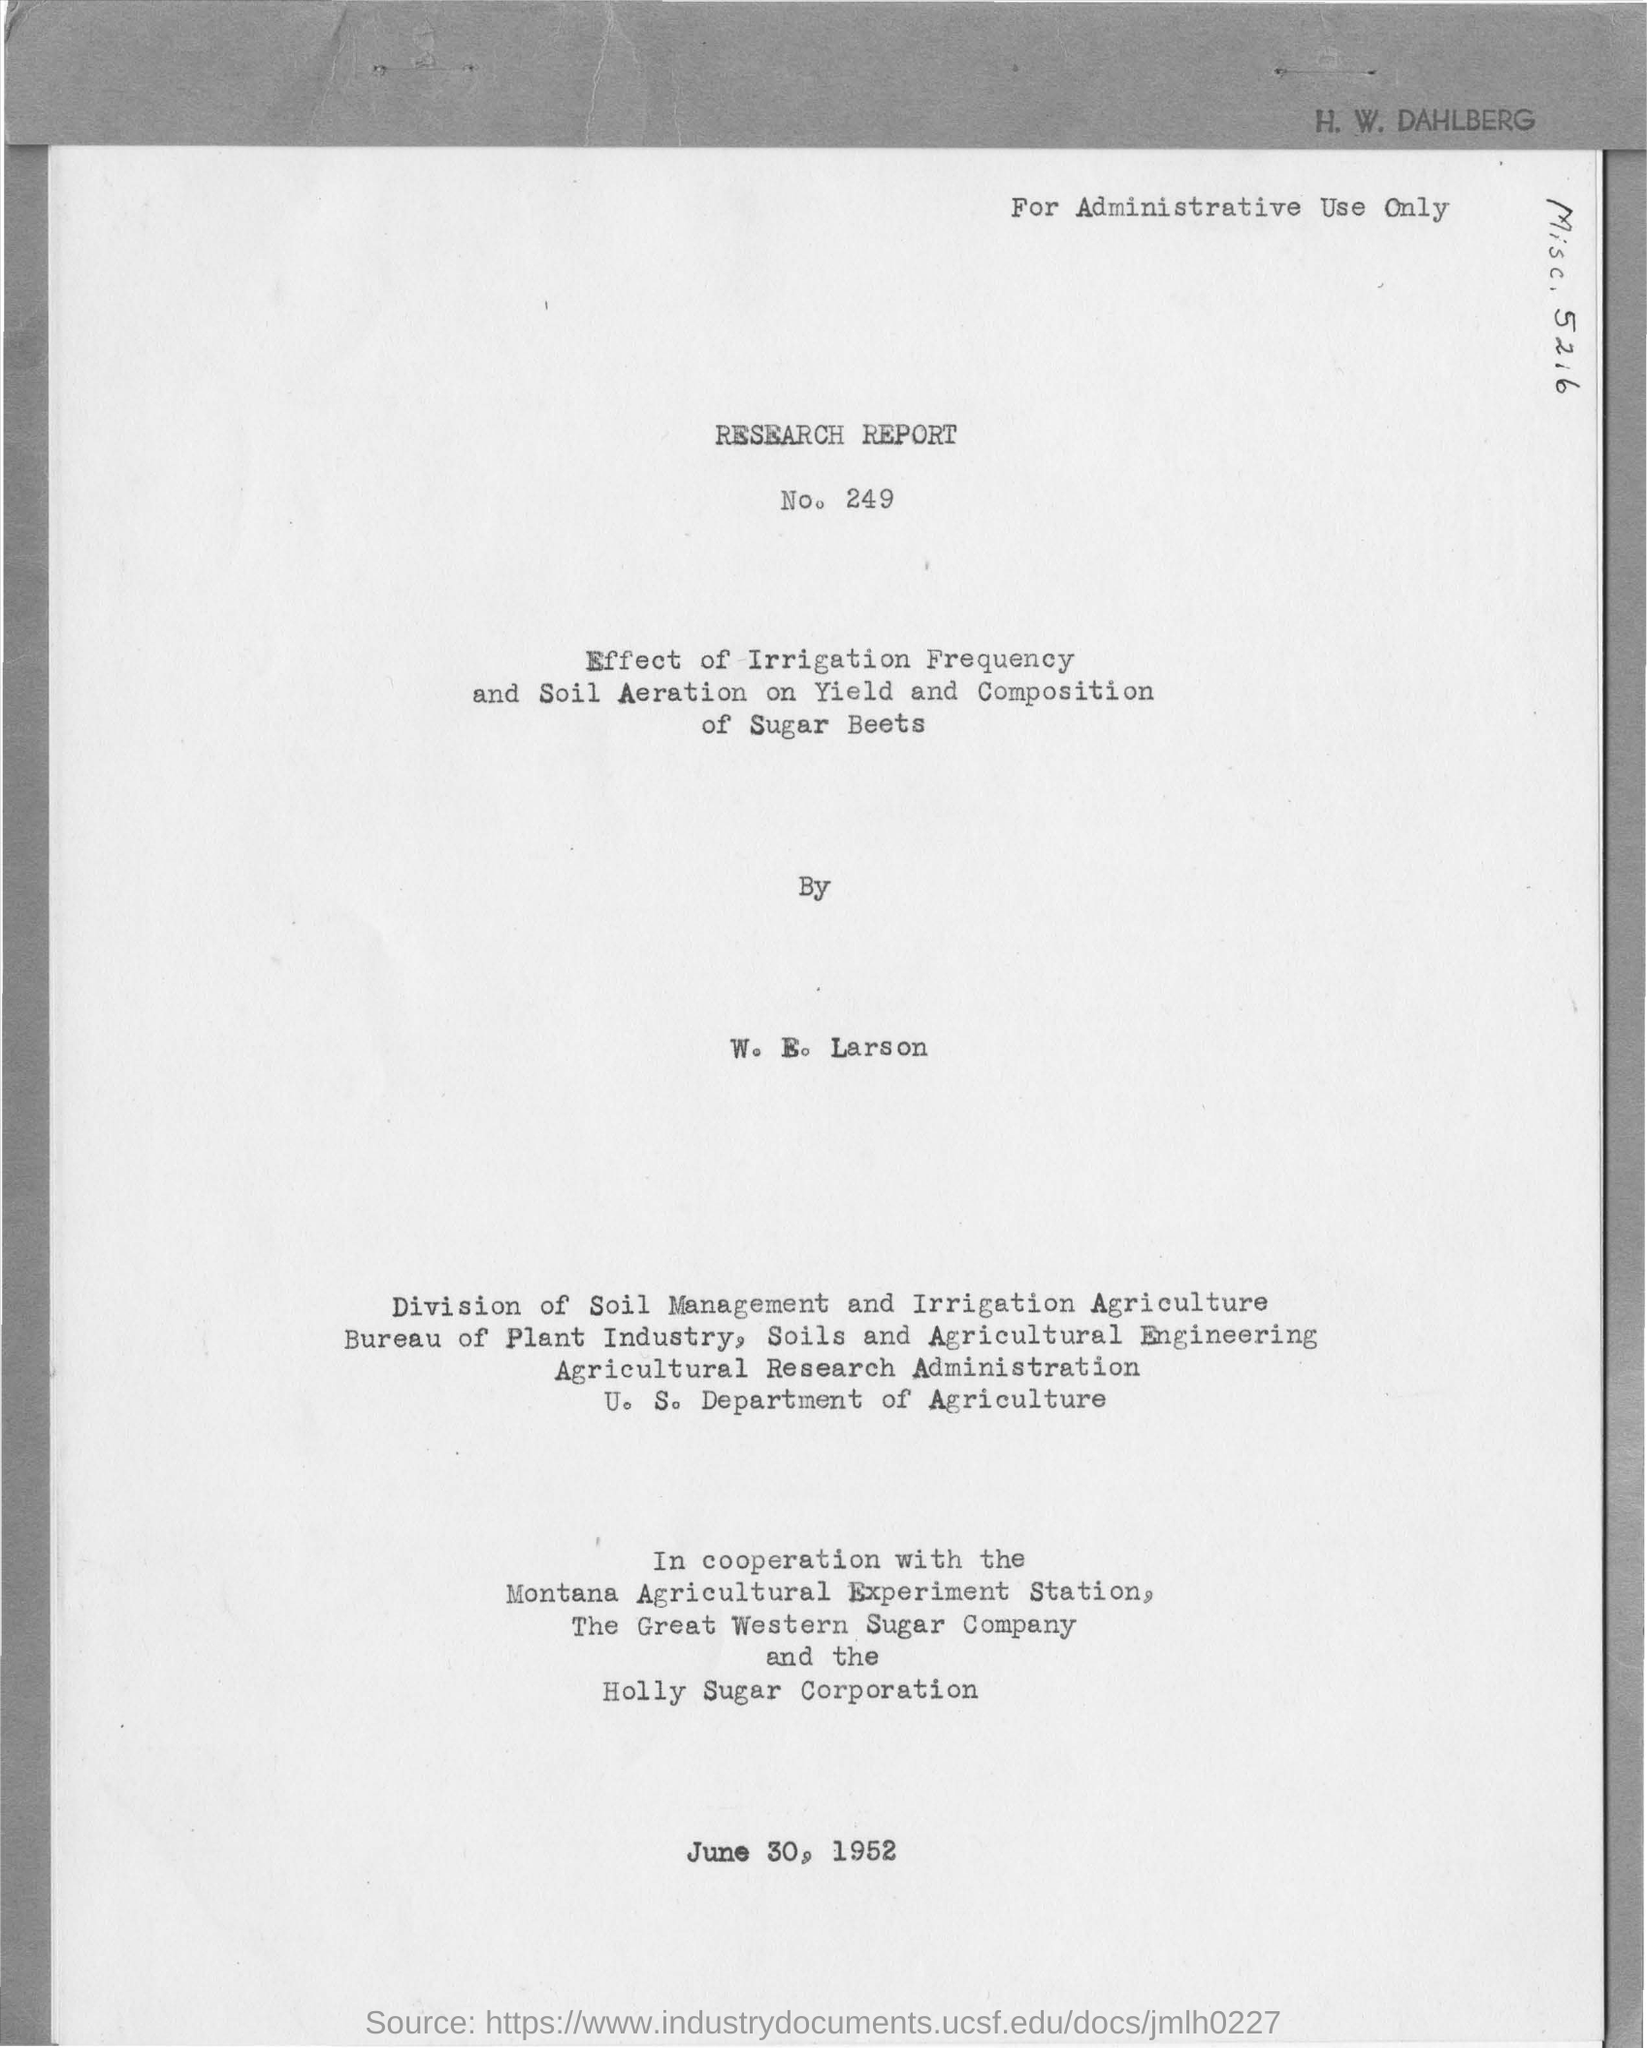Give some essential details in this illustration. The number written below the Research Report is 249. The name mentioned at the top right of the document is H. W. Dahlberg. The date mentioned in the bottom of the document is June 30, 1952. The name written in the below text is W. E. Larson. 